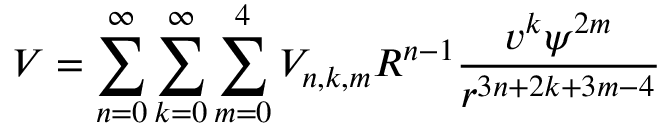<formula> <loc_0><loc_0><loc_500><loc_500>V = \sum _ { n = 0 } ^ { \infty } \sum _ { k = 0 } ^ { \infty } \sum _ { m = 0 } ^ { 4 } V _ { n , k , m } R ^ { n - 1 } \frac { v ^ { k } \psi ^ { 2 m } } { r ^ { 3 n + 2 k + 3 m - 4 } }</formula> 